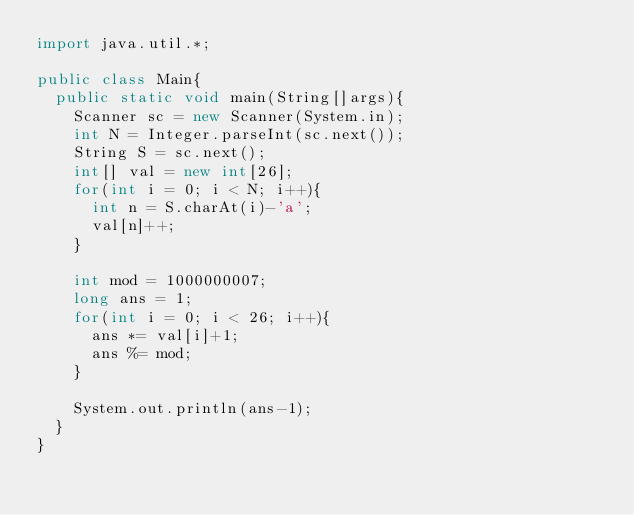<code> <loc_0><loc_0><loc_500><loc_500><_Java_>import java.util.*;

public class Main{
  public static void main(String[]args){
    Scanner sc = new Scanner(System.in);
    int N = Integer.parseInt(sc.next());
    String S = sc.next();
    int[] val = new int[26];
    for(int i = 0; i < N; i++){
      int n = S.charAt(i)-'a';
      val[n]++;
    }
    
    int mod = 1000000007;
    long ans = 1;
    for(int i = 0; i < 26; i++){
      ans *= val[i]+1;
      ans %= mod;
    }
    
    System.out.println(ans-1);
  }
}</code> 